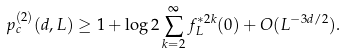<formula> <loc_0><loc_0><loc_500><loc_500>p _ { c } ^ { ( 2 ) } ( d , L ) \geq 1 + \log 2 \sum _ { k = 2 } ^ { \infty } f _ { L } ^ { \ast 2 k } ( 0 ) + O ( L ^ { - 3 d / 2 } ) .</formula> 